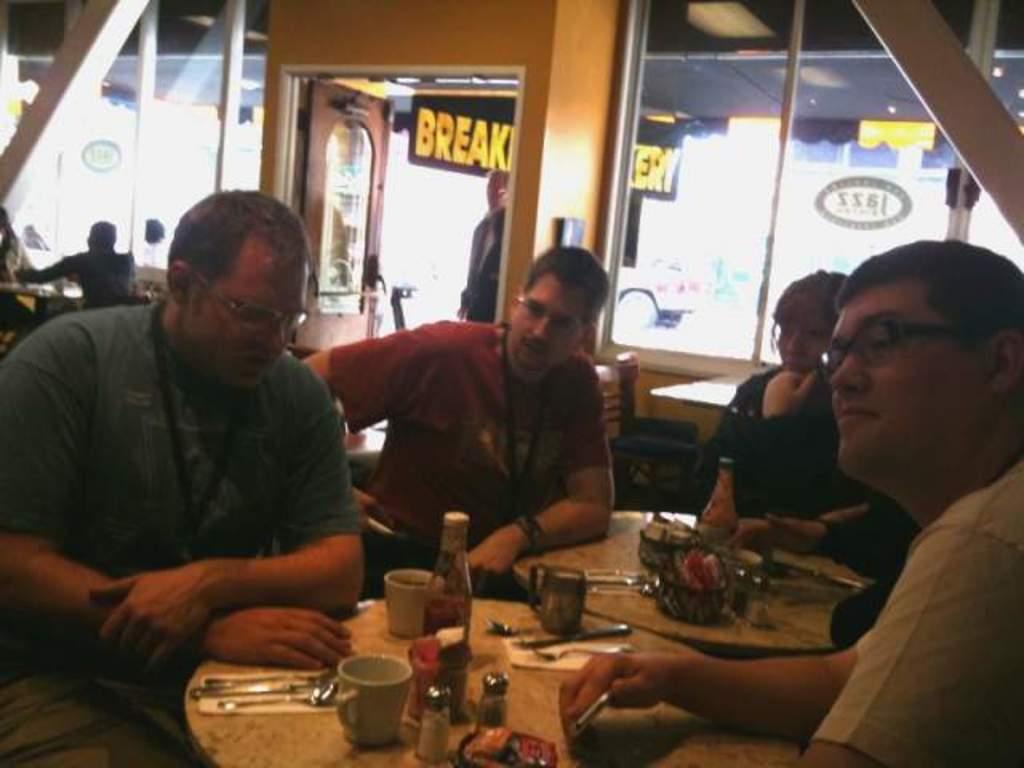Please provide a concise description of this image. In this picture we can see four persons are sitting in front of tables, there are bottles, mugs, spoons and knives present on these tables, in the background we can see three more persons, a board and glasses, there is some text on this board. 